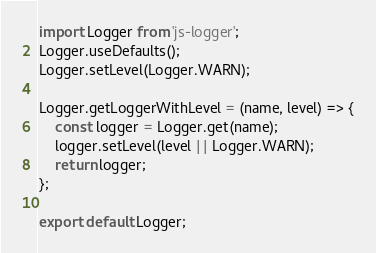<code> <loc_0><loc_0><loc_500><loc_500><_JavaScript_>import Logger from 'js-logger';
Logger.useDefaults();
Logger.setLevel(Logger.WARN);

Logger.getLoggerWithLevel = (name, level) => {
    const logger = Logger.get(name);
    logger.setLevel(level || Logger.WARN);
    return logger;
};

export default Logger;</code> 